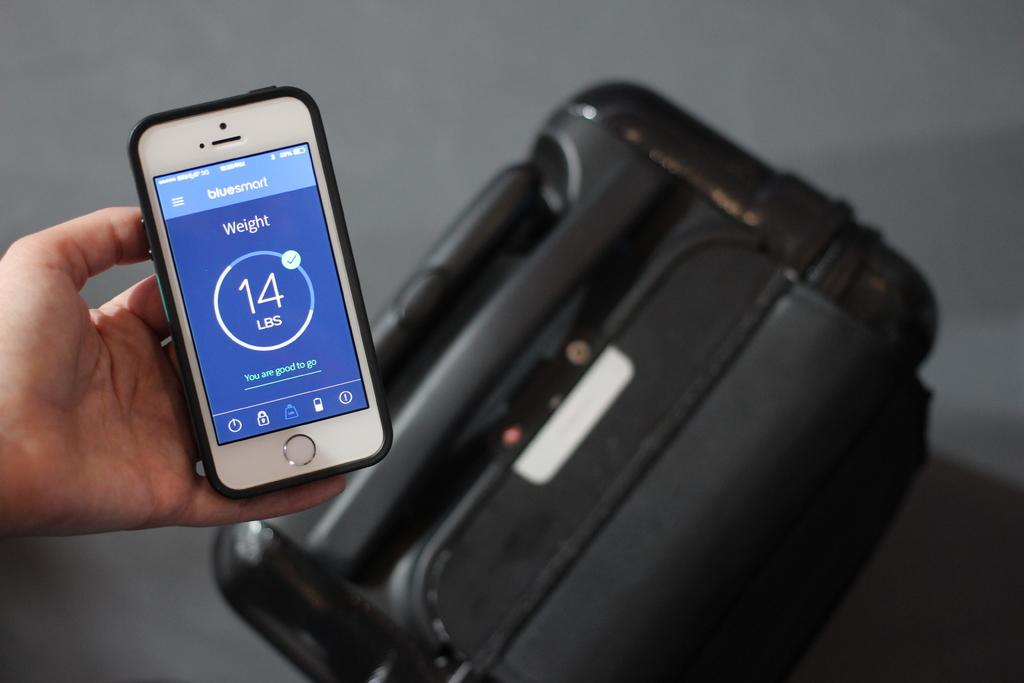<image>
Provide a brief description of the given image. Bluesmart is the name of an app that gives weight info. 